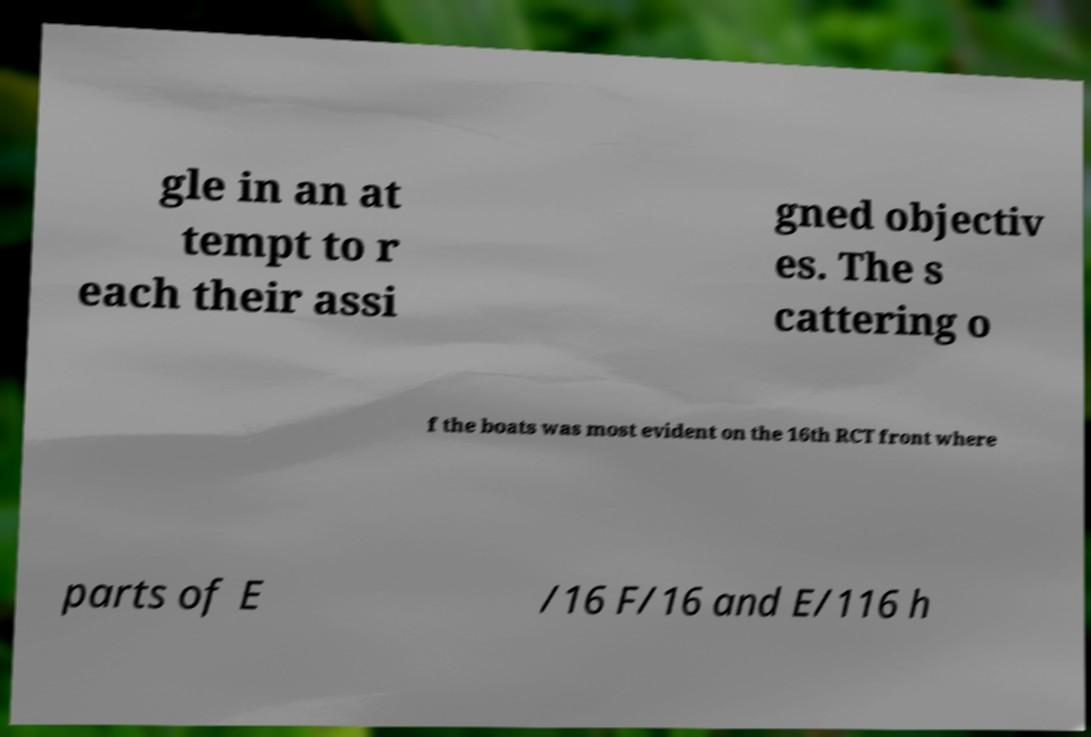For documentation purposes, I need the text within this image transcribed. Could you provide that? gle in an at tempt to r each their assi gned objectiv es. The s cattering o f the boats was most evident on the 16th RCT front where parts of E /16 F/16 and E/116 h 